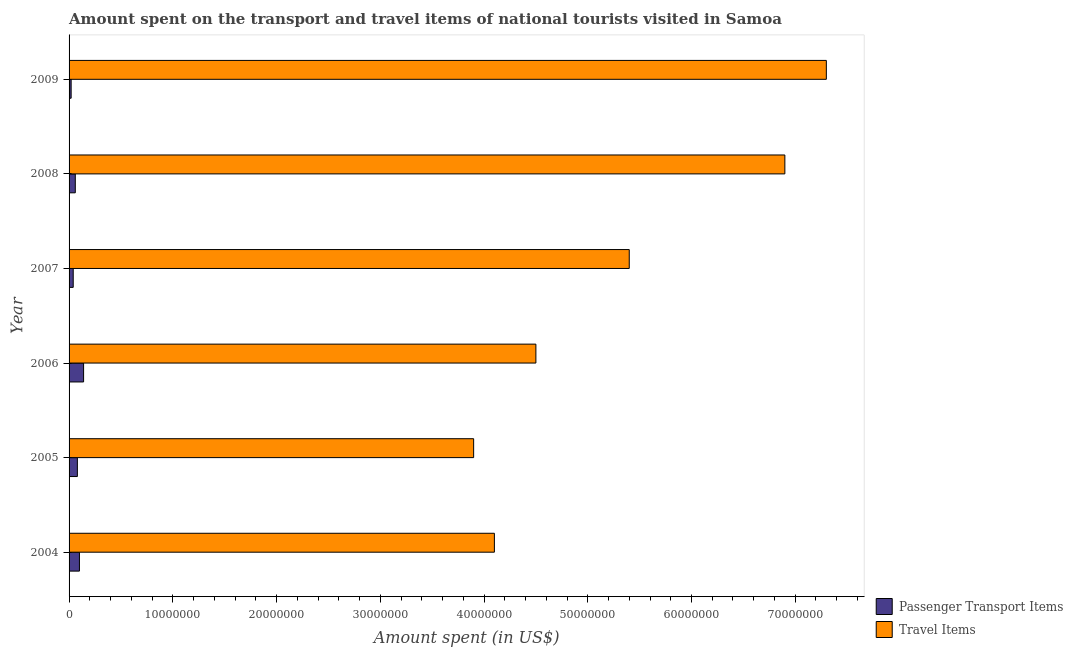How many different coloured bars are there?
Offer a very short reply. 2. Are the number of bars per tick equal to the number of legend labels?
Keep it short and to the point. Yes. In how many cases, is the number of bars for a given year not equal to the number of legend labels?
Your response must be concise. 0. What is the amount spent in travel items in 2005?
Provide a succinct answer. 3.90e+07. Across all years, what is the maximum amount spent on passenger transport items?
Offer a terse response. 1.40e+06. Across all years, what is the minimum amount spent in travel items?
Make the answer very short. 3.90e+07. In which year was the amount spent in travel items minimum?
Offer a very short reply. 2005. What is the total amount spent on passenger transport items in the graph?
Ensure brevity in your answer.  4.40e+06. What is the difference between the amount spent on passenger transport items in 2008 and the amount spent in travel items in 2005?
Make the answer very short. -3.84e+07. What is the average amount spent on passenger transport items per year?
Give a very brief answer. 7.33e+05. In the year 2008, what is the difference between the amount spent on passenger transport items and amount spent in travel items?
Offer a terse response. -6.84e+07. In how many years, is the amount spent on passenger transport items greater than 54000000 US$?
Provide a short and direct response. 0. What is the ratio of the amount spent in travel items in 2006 to that in 2008?
Ensure brevity in your answer.  0.65. Is the difference between the amount spent in travel items in 2004 and 2009 greater than the difference between the amount spent on passenger transport items in 2004 and 2009?
Give a very brief answer. No. What is the difference between the highest and the lowest amount spent on passenger transport items?
Keep it short and to the point. 1.20e+06. In how many years, is the amount spent on passenger transport items greater than the average amount spent on passenger transport items taken over all years?
Ensure brevity in your answer.  3. Is the sum of the amount spent in travel items in 2006 and 2009 greater than the maximum amount spent on passenger transport items across all years?
Keep it short and to the point. Yes. What does the 2nd bar from the top in 2006 represents?
Provide a short and direct response. Passenger Transport Items. What does the 1st bar from the bottom in 2008 represents?
Your answer should be compact. Passenger Transport Items. How many bars are there?
Your response must be concise. 12. Are all the bars in the graph horizontal?
Provide a short and direct response. Yes. What is the difference between two consecutive major ticks on the X-axis?
Your answer should be very brief. 1.00e+07. Are the values on the major ticks of X-axis written in scientific E-notation?
Give a very brief answer. No. How many legend labels are there?
Offer a very short reply. 2. What is the title of the graph?
Provide a succinct answer. Amount spent on the transport and travel items of national tourists visited in Samoa. What is the label or title of the X-axis?
Your answer should be compact. Amount spent (in US$). What is the label or title of the Y-axis?
Keep it short and to the point. Year. What is the Amount spent (in US$) in Passenger Transport Items in 2004?
Keep it short and to the point. 1.00e+06. What is the Amount spent (in US$) in Travel Items in 2004?
Provide a succinct answer. 4.10e+07. What is the Amount spent (in US$) of Travel Items in 2005?
Keep it short and to the point. 3.90e+07. What is the Amount spent (in US$) in Passenger Transport Items in 2006?
Keep it short and to the point. 1.40e+06. What is the Amount spent (in US$) of Travel Items in 2006?
Give a very brief answer. 4.50e+07. What is the Amount spent (in US$) of Passenger Transport Items in 2007?
Your answer should be very brief. 4.00e+05. What is the Amount spent (in US$) in Travel Items in 2007?
Your answer should be very brief. 5.40e+07. What is the Amount spent (in US$) of Passenger Transport Items in 2008?
Provide a succinct answer. 6.00e+05. What is the Amount spent (in US$) in Travel Items in 2008?
Offer a terse response. 6.90e+07. What is the Amount spent (in US$) in Passenger Transport Items in 2009?
Your answer should be compact. 2.00e+05. What is the Amount spent (in US$) of Travel Items in 2009?
Provide a short and direct response. 7.30e+07. Across all years, what is the maximum Amount spent (in US$) in Passenger Transport Items?
Provide a short and direct response. 1.40e+06. Across all years, what is the maximum Amount spent (in US$) in Travel Items?
Offer a very short reply. 7.30e+07. Across all years, what is the minimum Amount spent (in US$) in Passenger Transport Items?
Provide a succinct answer. 2.00e+05. Across all years, what is the minimum Amount spent (in US$) in Travel Items?
Give a very brief answer. 3.90e+07. What is the total Amount spent (in US$) of Passenger Transport Items in the graph?
Your answer should be very brief. 4.40e+06. What is the total Amount spent (in US$) of Travel Items in the graph?
Ensure brevity in your answer.  3.21e+08. What is the difference between the Amount spent (in US$) of Passenger Transport Items in 2004 and that in 2005?
Provide a succinct answer. 2.00e+05. What is the difference between the Amount spent (in US$) in Travel Items in 2004 and that in 2005?
Make the answer very short. 2.00e+06. What is the difference between the Amount spent (in US$) of Passenger Transport Items in 2004 and that in 2006?
Offer a very short reply. -4.00e+05. What is the difference between the Amount spent (in US$) of Travel Items in 2004 and that in 2007?
Your response must be concise. -1.30e+07. What is the difference between the Amount spent (in US$) in Passenger Transport Items in 2004 and that in 2008?
Make the answer very short. 4.00e+05. What is the difference between the Amount spent (in US$) in Travel Items in 2004 and that in 2008?
Your answer should be very brief. -2.80e+07. What is the difference between the Amount spent (in US$) in Travel Items in 2004 and that in 2009?
Make the answer very short. -3.20e+07. What is the difference between the Amount spent (in US$) of Passenger Transport Items in 2005 and that in 2006?
Offer a terse response. -6.00e+05. What is the difference between the Amount spent (in US$) in Travel Items in 2005 and that in 2006?
Provide a short and direct response. -6.00e+06. What is the difference between the Amount spent (in US$) of Travel Items in 2005 and that in 2007?
Your answer should be very brief. -1.50e+07. What is the difference between the Amount spent (in US$) in Travel Items in 2005 and that in 2008?
Ensure brevity in your answer.  -3.00e+07. What is the difference between the Amount spent (in US$) in Passenger Transport Items in 2005 and that in 2009?
Give a very brief answer. 6.00e+05. What is the difference between the Amount spent (in US$) in Travel Items in 2005 and that in 2009?
Provide a short and direct response. -3.40e+07. What is the difference between the Amount spent (in US$) in Passenger Transport Items in 2006 and that in 2007?
Provide a succinct answer. 1.00e+06. What is the difference between the Amount spent (in US$) of Travel Items in 2006 and that in 2007?
Provide a succinct answer. -9.00e+06. What is the difference between the Amount spent (in US$) of Passenger Transport Items in 2006 and that in 2008?
Offer a terse response. 8.00e+05. What is the difference between the Amount spent (in US$) of Travel Items in 2006 and that in 2008?
Provide a succinct answer. -2.40e+07. What is the difference between the Amount spent (in US$) in Passenger Transport Items in 2006 and that in 2009?
Ensure brevity in your answer.  1.20e+06. What is the difference between the Amount spent (in US$) of Travel Items in 2006 and that in 2009?
Your answer should be very brief. -2.80e+07. What is the difference between the Amount spent (in US$) of Passenger Transport Items in 2007 and that in 2008?
Your answer should be very brief. -2.00e+05. What is the difference between the Amount spent (in US$) of Travel Items in 2007 and that in 2008?
Your response must be concise. -1.50e+07. What is the difference between the Amount spent (in US$) of Travel Items in 2007 and that in 2009?
Keep it short and to the point. -1.90e+07. What is the difference between the Amount spent (in US$) in Passenger Transport Items in 2004 and the Amount spent (in US$) in Travel Items in 2005?
Offer a terse response. -3.80e+07. What is the difference between the Amount spent (in US$) in Passenger Transport Items in 2004 and the Amount spent (in US$) in Travel Items in 2006?
Provide a short and direct response. -4.40e+07. What is the difference between the Amount spent (in US$) in Passenger Transport Items in 2004 and the Amount spent (in US$) in Travel Items in 2007?
Offer a very short reply. -5.30e+07. What is the difference between the Amount spent (in US$) in Passenger Transport Items in 2004 and the Amount spent (in US$) in Travel Items in 2008?
Ensure brevity in your answer.  -6.80e+07. What is the difference between the Amount spent (in US$) of Passenger Transport Items in 2004 and the Amount spent (in US$) of Travel Items in 2009?
Keep it short and to the point. -7.20e+07. What is the difference between the Amount spent (in US$) of Passenger Transport Items in 2005 and the Amount spent (in US$) of Travel Items in 2006?
Ensure brevity in your answer.  -4.42e+07. What is the difference between the Amount spent (in US$) of Passenger Transport Items in 2005 and the Amount spent (in US$) of Travel Items in 2007?
Give a very brief answer. -5.32e+07. What is the difference between the Amount spent (in US$) of Passenger Transport Items in 2005 and the Amount spent (in US$) of Travel Items in 2008?
Give a very brief answer. -6.82e+07. What is the difference between the Amount spent (in US$) in Passenger Transport Items in 2005 and the Amount spent (in US$) in Travel Items in 2009?
Your answer should be very brief. -7.22e+07. What is the difference between the Amount spent (in US$) of Passenger Transport Items in 2006 and the Amount spent (in US$) of Travel Items in 2007?
Your answer should be very brief. -5.26e+07. What is the difference between the Amount spent (in US$) of Passenger Transport Items in 2006 and the Amount spent (in US$) of Travel Items in 2008?
Keep it short and to the point. -6.76e+07. What is the difference between the Amount spent (in US$) in Passenger Transport Items in 2006 and the Amount spent (in US$) in Travel Items in 2009?
Keep it short and to the point. -7.16e+07. What is the difference between the Amount spent (in US$) in Passenger Transport Items in 2007 and the Amount spent (in US$) in Travel Items in 2008?
Ensure brevity in your answer.  -6.86e+07. What is the difference between the Amount spent (in US$) in Passenger Transport Items in 2007 and the Amount spent (in US$) in Travel Items in 2009?
Provide a succinct answer. -7.26e+07. What is the difference between the Amount spent (in US$) of Passenger Transport Items in 2008 and the Amount spent (in US$) of Travel Items in 2009?
Offer a very short reply. -7.24e+07. What is the average Amount spent (in US$) in Passenger Transport Items per year?
Ensure brevity in your answer.  7.33e+05. What is the average Amount spent (in US$) in Travel Items per year?
Your response must be concise. 5.35e+07. In the year 2004, what is the difference between the Amount spent (in US$) in Passenger Transport Items and Amount spent (in US$) in Travel Items?
Your answer should be very brief. -4.00e+07. In the year 2005, what is the difference between the Amount spent (in US$) in Passenger Transport Items and Amount spent (in US$) in Travel Items?
Give a very brief answer. -3.82e+07. In the year 2006, what is the difference between the Amount spent (in US$) in Passenger Transport Items and Amount spent (in US$) in Travel Items?
Provide a short and direct response. -4.36e+07. In the year 2007, what is the difference between the Amount spent (in US$) of Passenger Transport Items and Amount spent (in US$) of Travel Items?
Ensure brevity in your answer.  -5.36e+07. In the year 2008, what is the difference between the Amount spent (in US$) in Passenger Transport Items and Amount spent (in US$) in Travel Items?
Ensure brevity in your answer.  -6.84e+07. In the year 2009, what is the difference between the Amount spent (in US$) in Passenger Transport Items and Amount spent (in US$) in Travel Items?
Provide a short and direct response. -7.28e+07. What is the ratio of the Amount spent (in US$) in Travel Items in 2004 to that in 2005?
Ensure brevity in your answer.  1.05. What is the ratio of the Amount spent (in US$) in Travel Items in 2004 to that in 2006?
Offer a very short reply. 0.91. What is the ratio of the Amount spent (in US$) of Travel Items in 2004 to that in 2007?
Give a very brief answer. 0.76. What is the ratio of the Amount spent (in US$) in Travel Items in 2004 to that in 2008?
Keep it short and to the point. 0.59. What is the ratio of the Amount spent (in US$) in Travel Items in 2004 to that in 2009?
Make the answer very short. 0.56. What is the ratio of the Amount spent (in US$) in Travel Items in 2005 to that in 2006?
Offer a terse response. 0.87. What is the ratio of the Amount spent (in US$) of Travel Items in 2005 to that in 2007?
Your response must be concise. 0.72. What is the ratio of the Amount spent (in US$) of Passenger Transport Items in 2005 to that in 2008?
Make the answer very short. 1.33. What is the ratio of the Amount spent (in US$) in Travel Items in 2005 to that in 2008?
Offer a very short reply. 0.57. What is the ratio of the Amount spent (in US$) in Passenger Transport Items in 2005 to that in 2009?
Your response must be concise. 4. What is the ratio of the Amount spent (in US$) in Travel Items in 2005 to that in 2009?
Your answer should be very brief. 0.53. What is the ratio of the Amount spent (in US$) in Passenger Transport Items in 2006 to that in 2008?
Ensure brevity in your answer.  2.33. What is the ratio of the Amount spent (in US$) of Travel Items in 2006 to that in 2008?
Ensure brevity in your answer.  0.65. What is the ratio of the Amount spent (in US$) in Passenger Transport Items in 2006 to that in 2009?
Make the answer very short. 7. What is the ratio of the Amount spent (in US$) of Travel Items in 2006 to that in 2009?
Offer a terse response. 0.62. What is the ratio of the Amount spent (in US$) in Passenger Transport Items in 2007 to that in 2008?
Your response must be concise. 0.67. What is the ratio of the Amount spent (in US$) in Travel Items in 2007 to that in 2008?
Your answer should be very brief. 0.78. What is the ratio of the Amount spent (in US$) in Passenger Transport Items in 2007 to that in 2009?
Make the answer very short. 2. What is the ratio of the Amount spent (in US$) of Travel Items in 2007 to that in 2009?
Provide a succinct answer. 0.74. What is the ratio of the Amount spent (in US$) of Passenger Transport Items in 2008 to that in 2009?
Give a very brief answer. 3. What is the ratio of the Amount spent (in US$) in Travel Items in 2008 to that in 2009?
Provide a short and direct response. 0.95. What is the difference between the highest and the second highest Amount spent (in US$) in Passenger Transport Items?
Make the answer very short. 4.00e+05. What is the difference between the highest and the lowest Amount spent (in US$) of Passenger Transport Items?
Your response must be concise. 1.20e+06. What is the difference between the highest and the lowest Amount spent (in US$) of Travel Items?
Provide a short and direct response. 3.40e+07. 